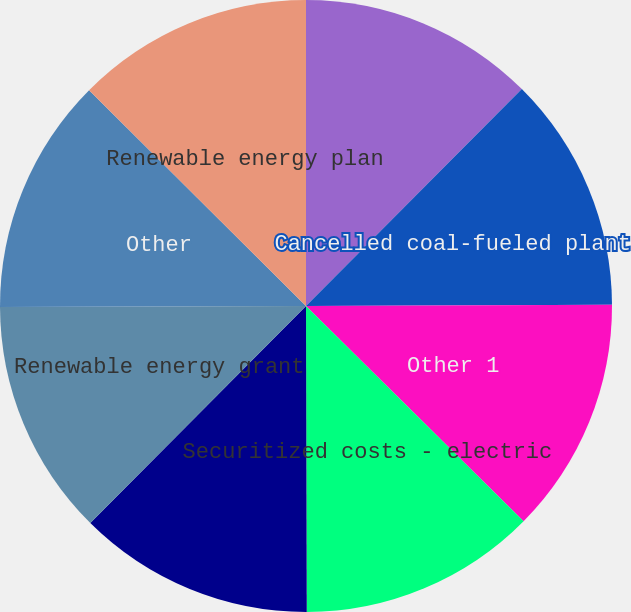<chart> <loc_0><loc_0><loc_500><loc_500><pie_chart><fcel>Energy optimization plan<fcel>Cancelled coal-fueled plant<fcel>Other 1<fcel>Securitized costs - electric<fcel>Income taxes net<fcel>Renewable energy grant<fcel>Other<fcel>Renewable energy plan<nl><fcel>12.46%<fcel>12.47%<fcel>12.48%<fcel>12.55%<fcel>12.49%<fcel>12.5%<fcel>12.51%<fcel>12.54%<nl></chart> 